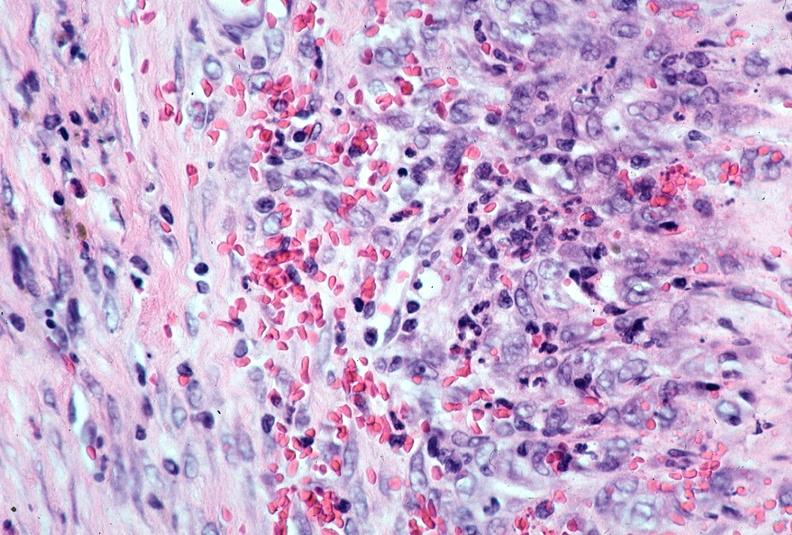s acute lymphocytic leukemia present?
Answer the question using a single word or phrase. No 